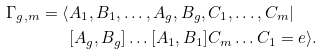Convert formula to latex. <formula><loc_0><loc_0><loc_500><loc_500>\Gamma _ { g , m } = \langle & A _ { 1 } , B _ { 1 } , \dots , A _ { g } , B _ { g } , C _ { 1 } , \dots , C _ { m } | \\ & [ A _ { g } , B _ { g } ] \dots [ A _ { 1 } , B _ { 1 } ] C _ { m } \dots C _ { 1 } = e \rangle .</formula> 